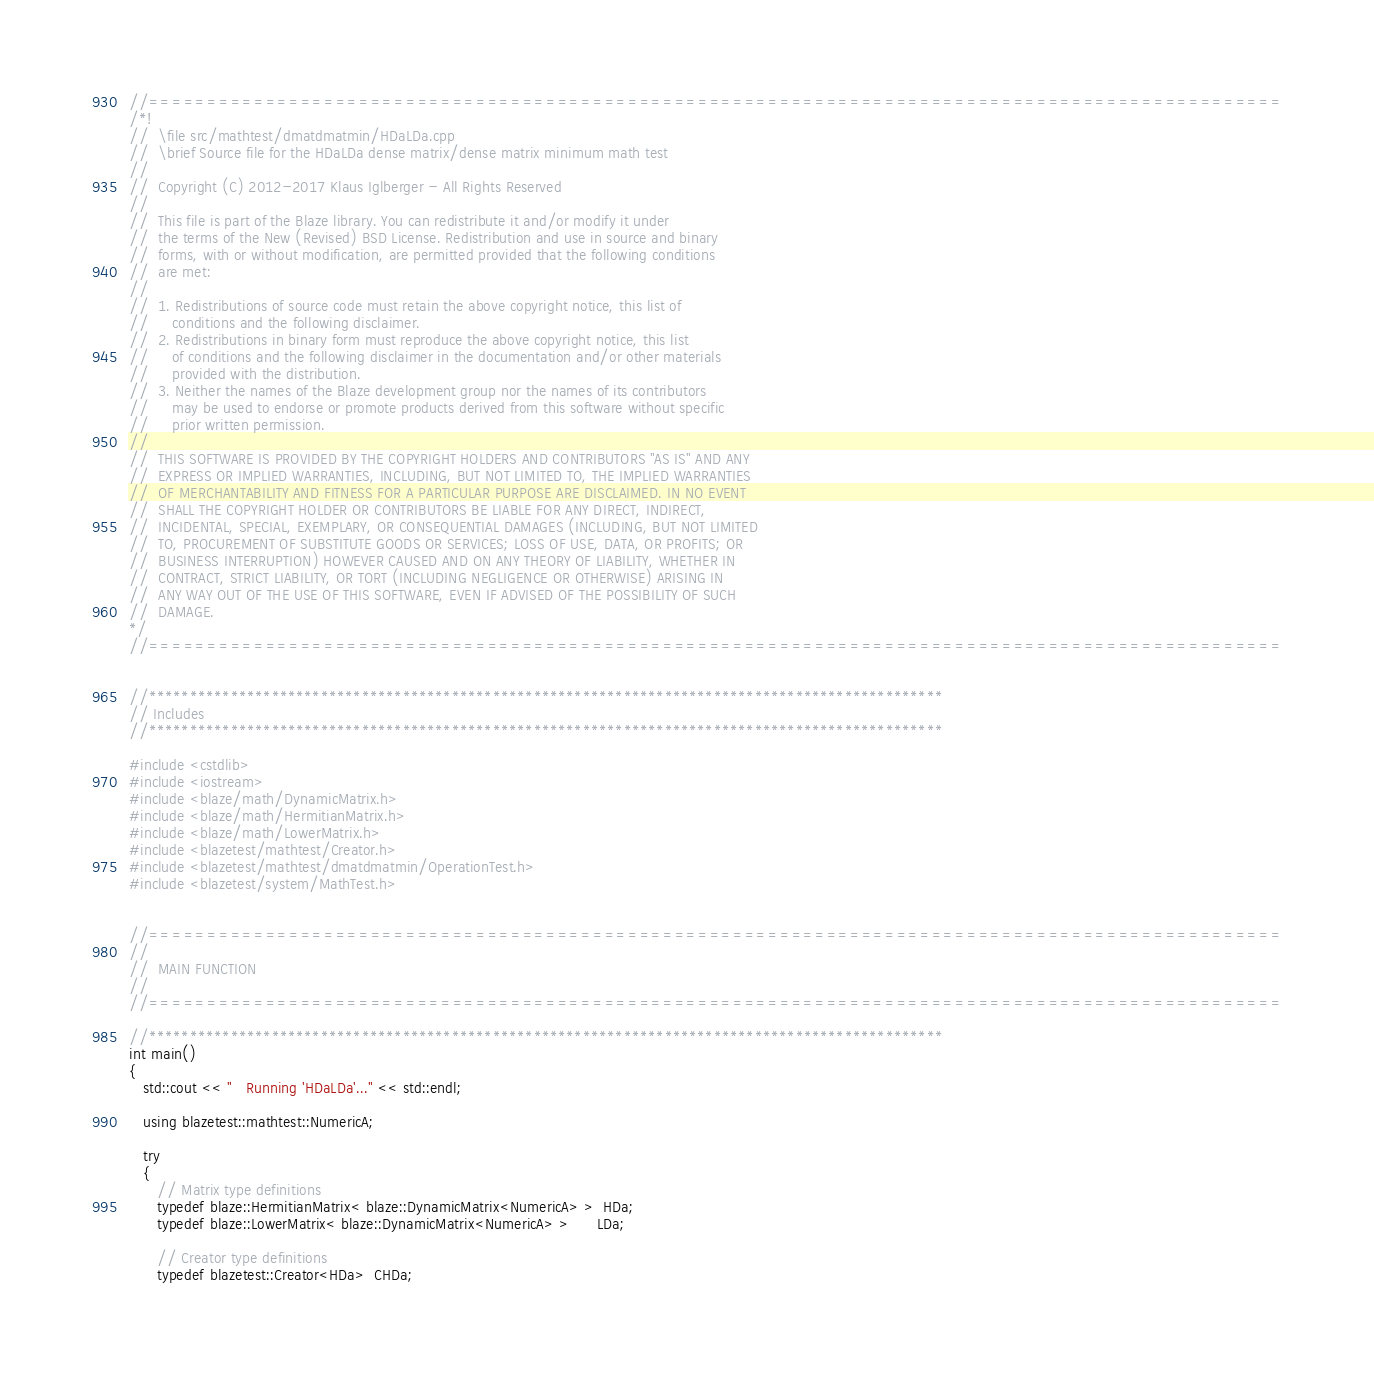Convert code to text. <code><loc_0><loc_0><loc_500><loc_500><_C++_>//=================================================================================================
/*!
//  \file src/mathtest/dmatdmatmin/HDaLDa.cpp
//  \brief Source file for the HDaLDa dense matrix/dense matrix minimum math test
//
//  Copyright (C) 2012-2017 Klaus Iglberger - All Rights Reserved
//
//  This file is part of the Blaze library. You can redistribute it and/or modify it under
//  the terms of the New (Revised) BSD License. Redistribution and use in source and binary
//  forms, with or without modification, are permitted provided that the following conditions
//  are met:
//
//  1. Redistributions of source code must retain the above copyright notice, this list of
//     conditions and the following disclaimer.
//  2. Redistributions in binary form must reproduce the above copyright notice, this list
//     of conditions and the following disclaimer in the documentation and/or other materials
//     provided with the distribution.
//  3. Neither the names of the Blaze development group nor the names of its contributors
//     may be used to endorse or promote products derived from this software without specific
//     prior written permission.
//
//  THIS SOFTWARE IS PROVIDED BY THE COPYRIGHT HOLDERS AND CONTRIBUTORS "AS IS" AND ANY
//  EXPRESS OR IMPLIED WARRANTIES, INCLUDING, BUT NOT LIMITED TO, THE IMPLIED WARRANTIES
//  OF MERCHANTABILITY AND FITNESS FOR A PARTICULAR PURPOSE ARE DISCLAIMED. IN NO EVENT
//  SHALL THE COPYRIGHT HOLDER OR CONTRIBUTORS BE LIABLE FOR ANY DIRECT, INDIRECT,
//  INCIDENTAL, SPECIAL, EXEMPLARY, OR CONSEQUENTIAL DAMAGES (INCLUDING, BUT NOT LIMITED
//  TO, PROCUREMENT OF SUBSTITUTE GOODS OR SERVICES; LOSS OF USE, DATA, OR PROFITS; OR
//  BUSINESS INTERRUPTION) HOWEVER CAUSED AND ON ANY THEORY OF LIABILITY, WHETHER IN
//  CONTRACT, STRICT LIABILITY, OR TORT (INCLUDING NEGLIGENCE OR OTHERWISE) ARISING IN
//  ANY WAY OUT OF THE USE OF THIS SOFTWARE, EVEN IF ADVISED OF THE POSSIBILITY OF SUCH
//  DAMAGE.
*/
//=================================================================================================


//*************************************************************************************************
// Includes
//*************************************************************************************************

#include <cstdlib>
#include <iostream>
#include <blaze/math/DynamicMatrix.h>
#include <blaze/math/HermitianMatrix.h>
#include <blaze/math/LowerMatrix.h>
#include <blazetest/mathtest/Creator.h>
#include <blazetest/mathtest/dmatdmatmin/OperationTest.h>
#include <blazetest/system/MathTest.h>


//=================================================================================================
//
//  MAIN FUNCTION
//
//=================================================================================================

//*************************************************************************************************
int main()
{
   std::cout << "   Running 'HDaLDa'..." << std::endl;

   using blazetest::mathtest::NumericA;

   try
   {
      // Matrix type definitions
      typedef blaze::HermitianMatrix< blaze::DynamicMatrix<NumericA> >  HDa;
      typedef blaze::LowerMatrix< blaze::DynamicMatrix<NumericA> >      LDa;

      // Creator type definitions
      typedef blazetest::Creator<HDa>  CHDa;</code> 